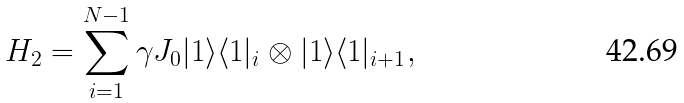Convert formula to latex. <formula><loc_0><loc_0><loc_500><loc_500>H _ { 2 } = \sum _ { i = 1 } ^ { N - 1 } \gamma J _ { 0 } | 1 \rangle \langle 1 | _ { i } \otimes | 1 \rangle \langle 1 | _ { i + 1 } ,</formula> 